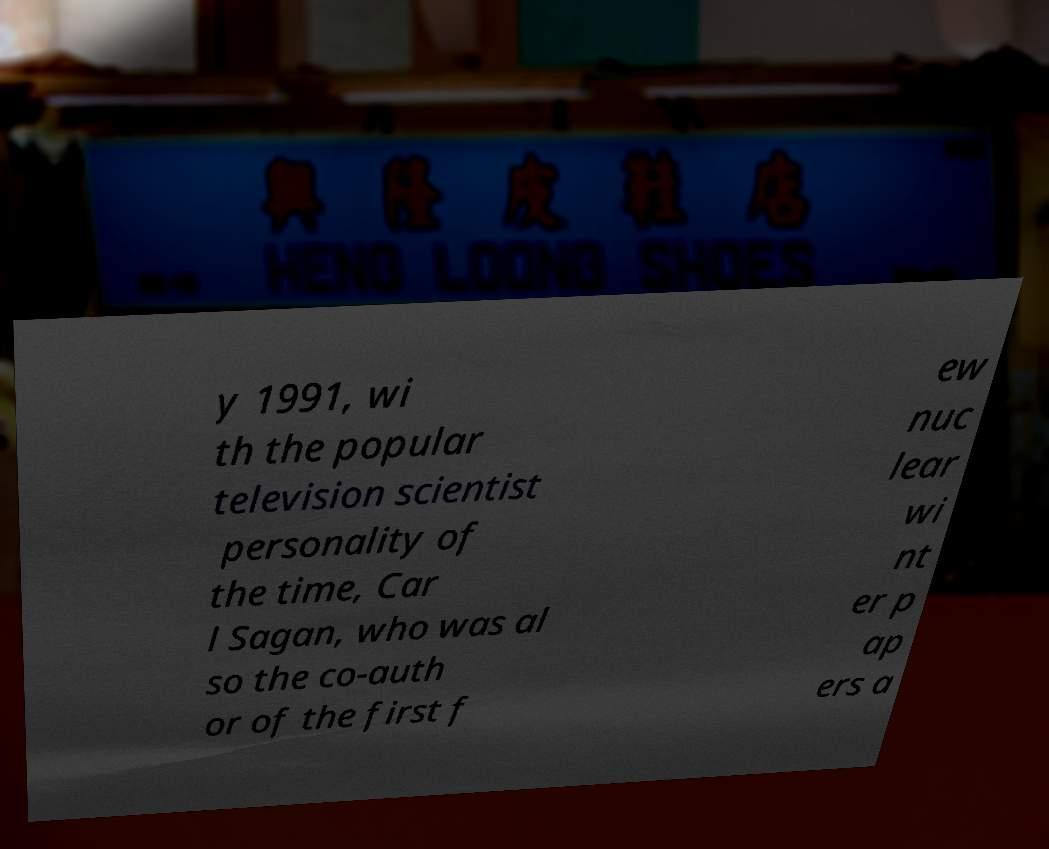Could you extract and type out the text from this image? y 1991, wi th the popular television scientist personality of the time, Car l Sagan, who was al so the co-auth or of the first f ew nuc lear wi nt er p ap ers a 